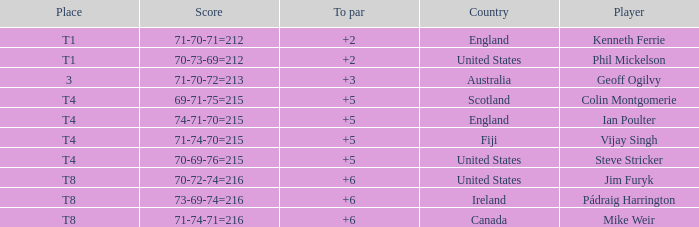Who had a score of 70-73-69=212? Phil Mickelson. Could you parse the entire table as a dict? {'header': ['Place', 'Score', 'To par', 'Country', 'Player'], 'rows': [['T1', '71-70-71=212', '+2', 'England', 'Kenneth Ferrie'], ['T1', '70-73-69=212', '+2', 'United States', 'Phil Mickelson'], ['3', '71-70-72=213', '+3', 'Australia', 'Geoff Ogilvy'], ['T4', '69-71-75=215', '+5', 'Scotland', 'Colin Montgomerie'], ['T4', '74-71-70=215', '+5', 'England', 'Ian Poulter'], ['T4', '71-74-70=215', '+5', 'Fiji', 'Vijay Singh'], ['T4', '70-69-76=215', '+5', 'United States', 'Steve Stricker'], ['T8', '70-72-74=216', '+6', 'United States', 'Jim Furyk'], ['T8', '73-69-74=216', '+6', 'Ireland', 'Pádraig Harrington'], ['T8', '71-74-71=216', '+6', 'Canada', 'Mike Weir']]} 